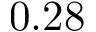Convert formula to latex. <formula><loc_0><loc_0><loc_500><loc_500>0 . 2 8</formula> 